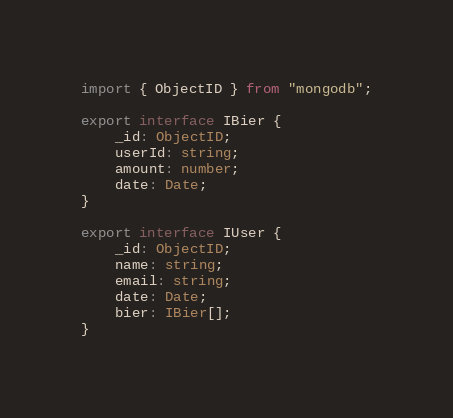Convert code to text. <code><loc_0><loc_0><loc_500><loc_500><_TypeScript_>import { ObjectID } from "mongodb";

export interface IBier {
    _id: ObjectID;
    userId: string;
    amount: number;
    date: Date;
}

export interface IUser {
    _id: ObjectID;
    name: string;
    email: string;
    date: Date;
    bier: IBier[];
}
</code> 